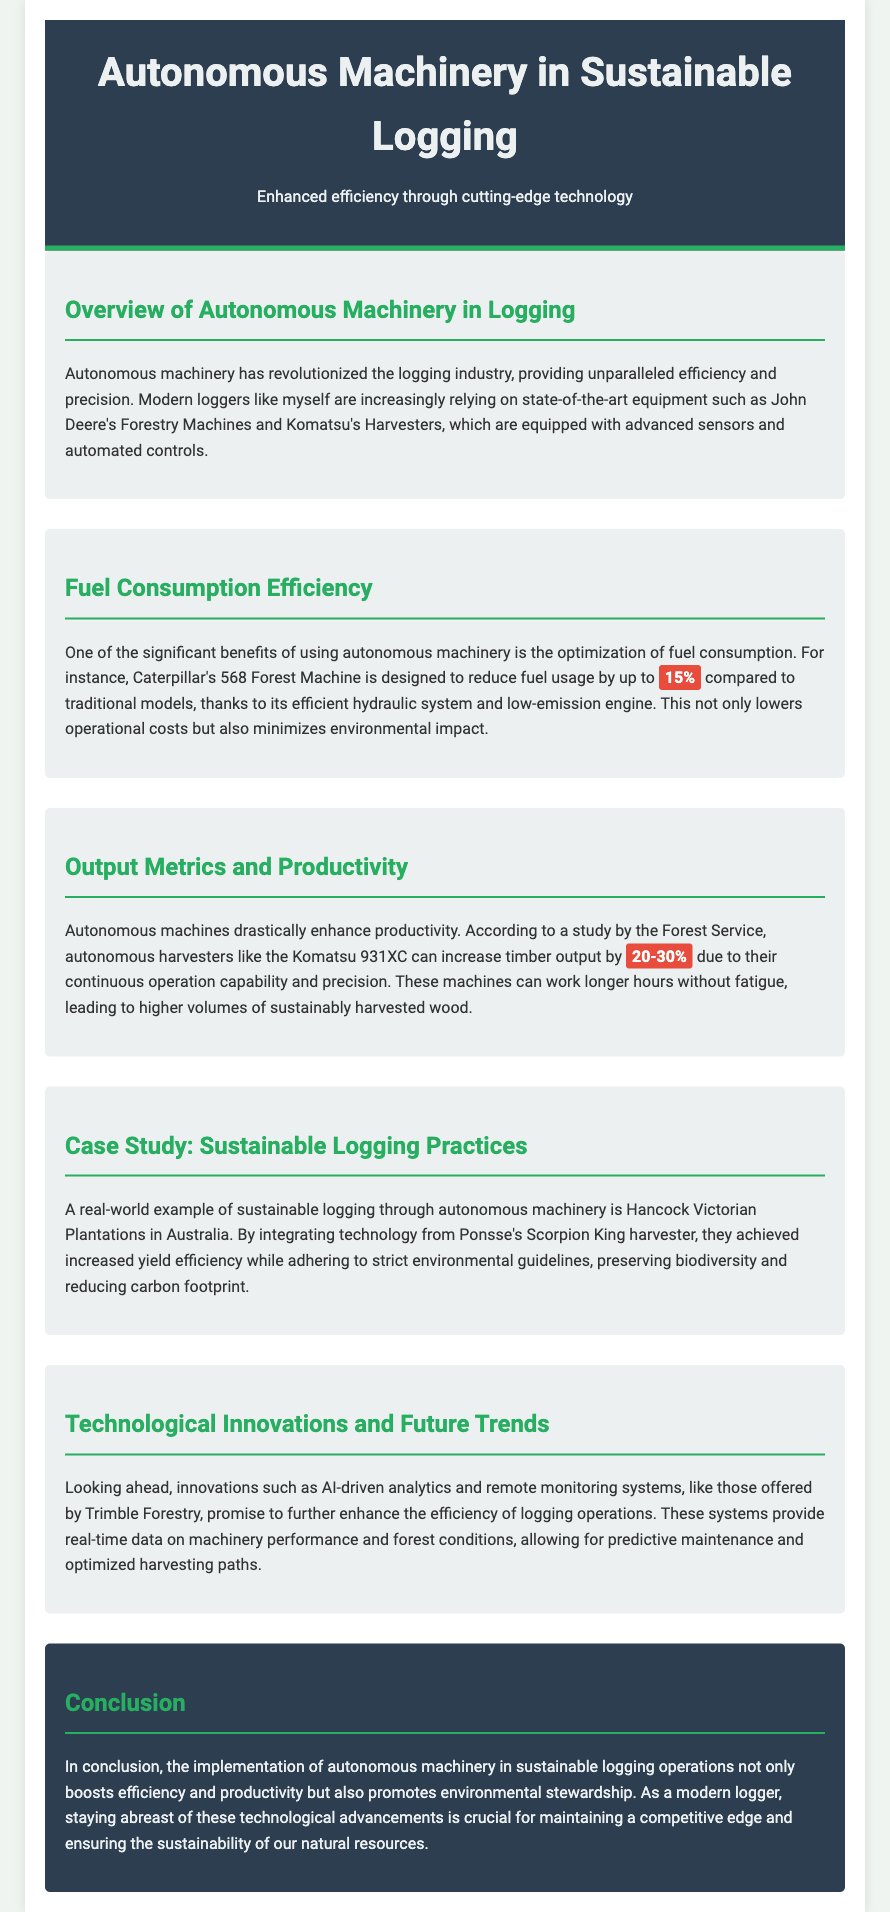What is one benefit of using autonomous machinery? The document states that autonomous machinery optimizes fuel consumption, which is a significant benefit.
Answer: Optimization of fuel consumption What is the percentage reduction in fuel usage provided by Caterpillar's 568 Forest Machine? It specifically mentions that the Caterpillar's machine reduces fuel usage by up to 15%.
Answer: 15% Which model of harvester can increase timber output by 20-30%? The document identifies the Komatsu 931XC as the model that can achieve this increase in timber output.
Answer: Komatsu 931XC What technology did Hancock Victorian Plantations integrate for sustainable logging? It mentions that they integrated technology from Ponsse's Scorpion King harvester for their practices.
Answer: Ponsse's Scorpion King harvester What system is mentioned for future trends in logging efficiency? The document refers to AI-driven analytics and remote monitoring systems as innovative future trends.
Answer: AI-driven analytics and remote monitoring systems How much higher timber output can autonomous machines achieve? The document states that autonomous machines can increase timber output by 20-30%.
Answer: 20-30% What environmental benefit is linked to the use of autonomous machinery? The document discusses that it minimizes environmental impact, particularly through reduced fuel consumption.
Answer: Minimizes environmental impact What company's forestry machines are mentioned in the document? The document mentions John Deere's Forestry Machines as equipment used in sustainable logging.
Answer: John Deere's Forestry Machines What is crucial for modern loggers to maintain a competitive edge? The conclusion states that keeping abreast of technological advancements is crucial for modern loggers.
Answer: Technological advancements 